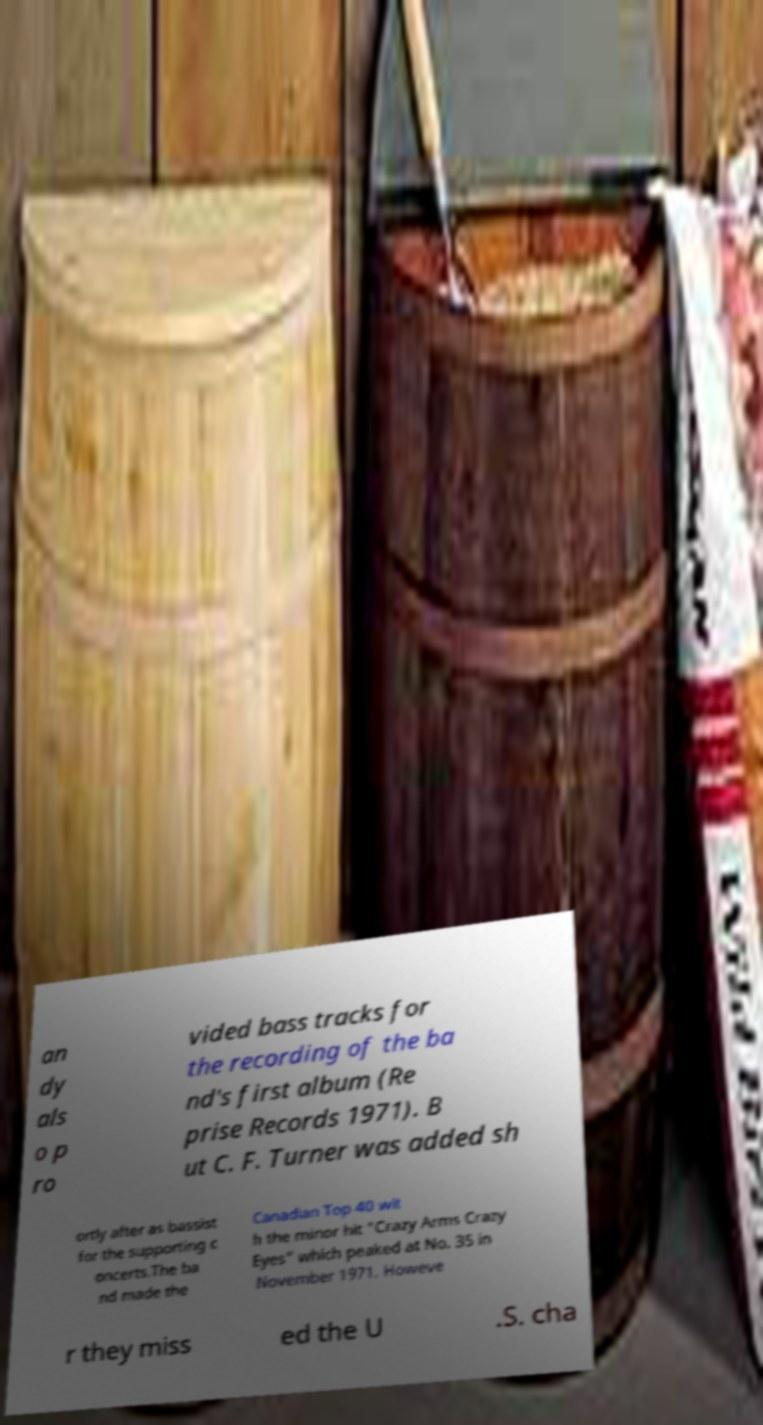Can you read and provide the text displayed in the image?This photo seems to have some interesting text. Can you extract and type it out for me? an dy als o p ro vided bass tracks for the recording of the ba nd's first album (Re prise Records 1971). B ut C. F. Turner was added sh ortly after as bassist for the supporting c oncerts.The ba nd made the Canadian Top 40 wit h the minor hit "Crazy Arms Crazy Eyes" which peaked at No. 35 in November 1971. Howeve r they miss ed the U .S. cha 